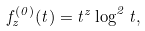Convert formula to latex. <formula><loc_0><loc_0><loc_500><loc_500>f _ { z } ^ { ( 0 ) } ( t ) = t ^ { z } \log ^ { 2 } t ,</formula> 